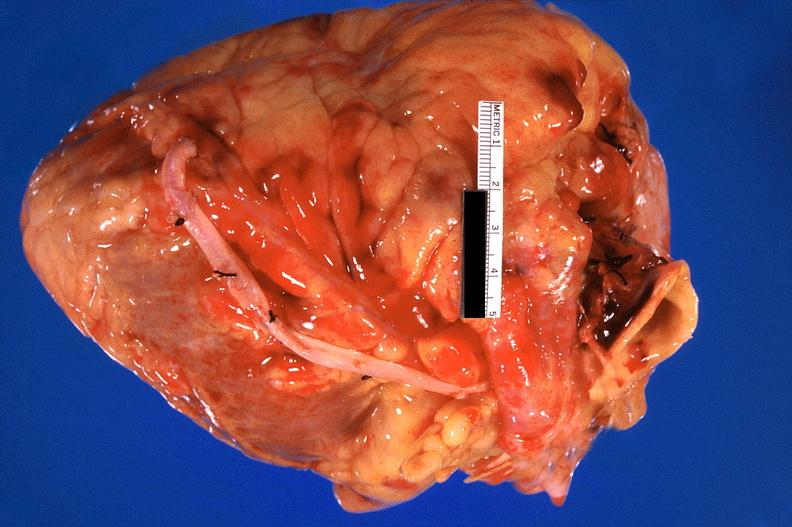what is present?
Answer the question using a single word or phrase. Cardiovascular 